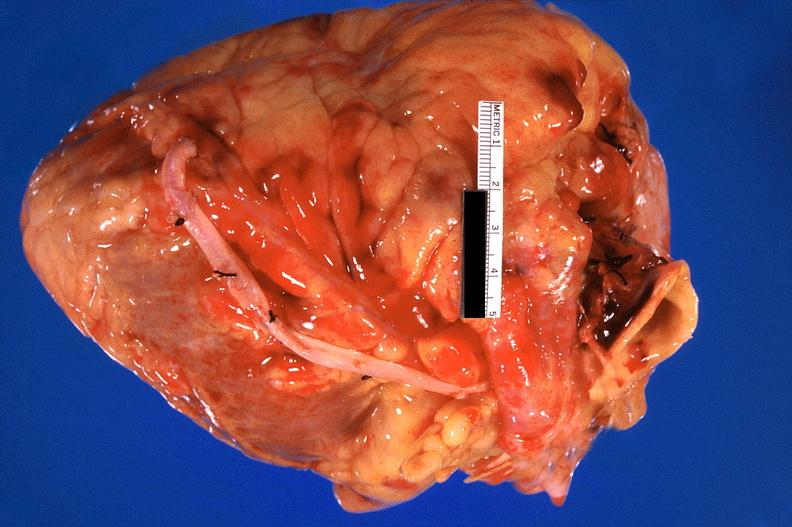what is present?
Answer the question using a single word or phrase. Cardiovascular 